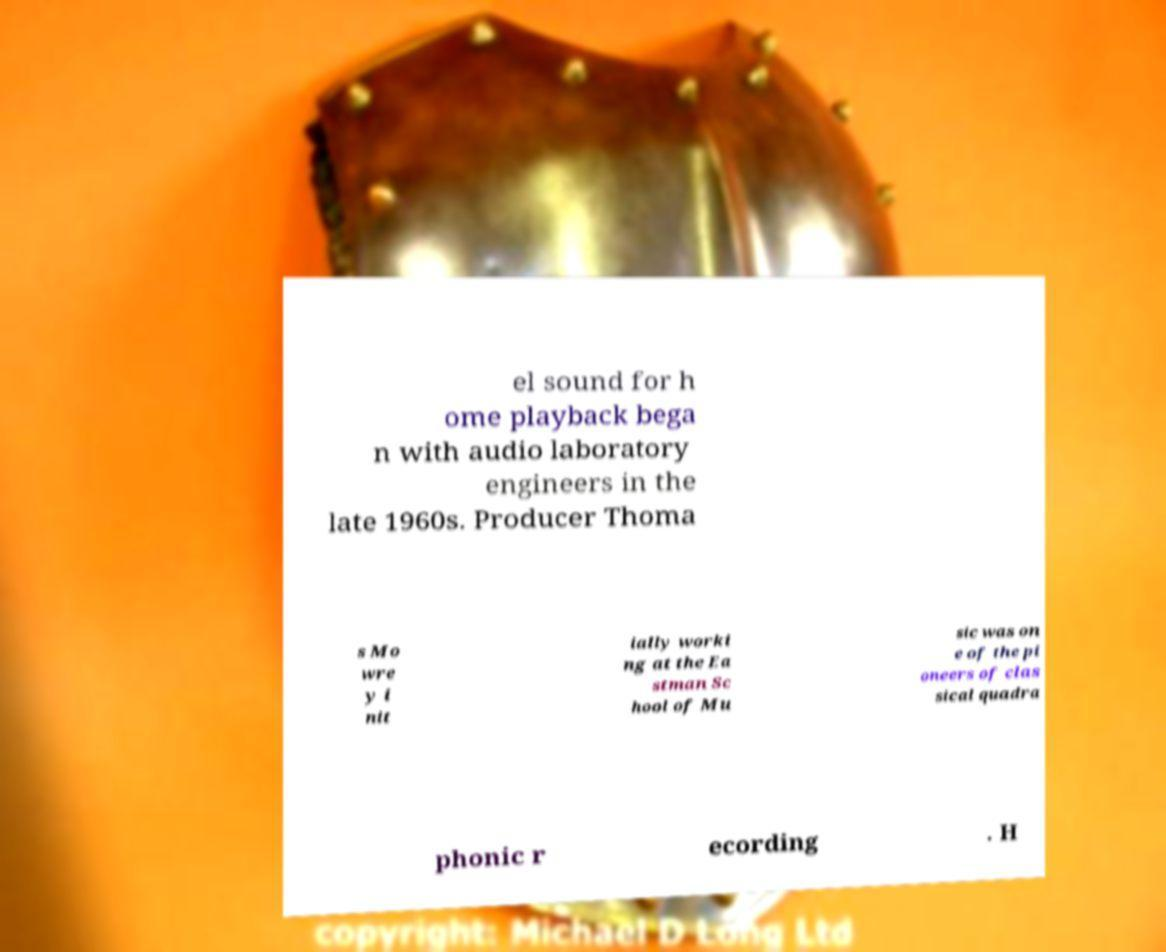Could you extract and type out the text from this image? el sound for h ome playback bega n with audio laboratory engineers in the late 1960s. Producer Thoma s Mo wre y i nit ially worki ng at the Ea stman Sc hool of Mu sic was on e of the pi oneers of clas sical quadra phonic r ecording . H 